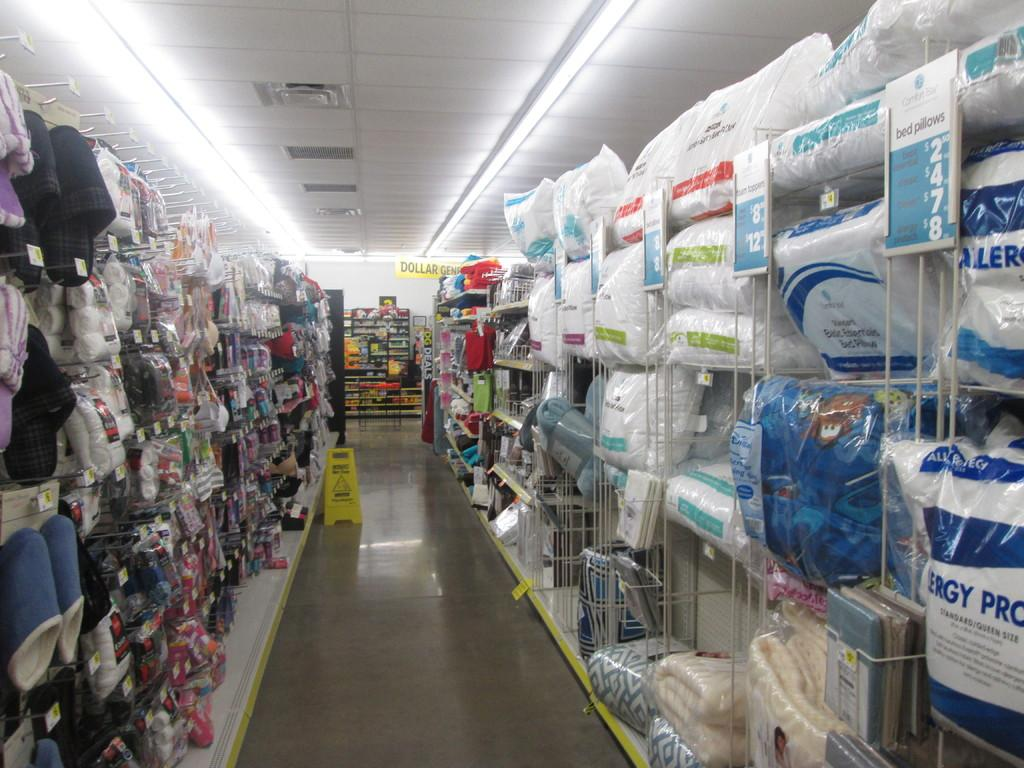<image>
Present a compact description of the photo's key features. A very cluttered store aisle has a yellow caution sign in it. 